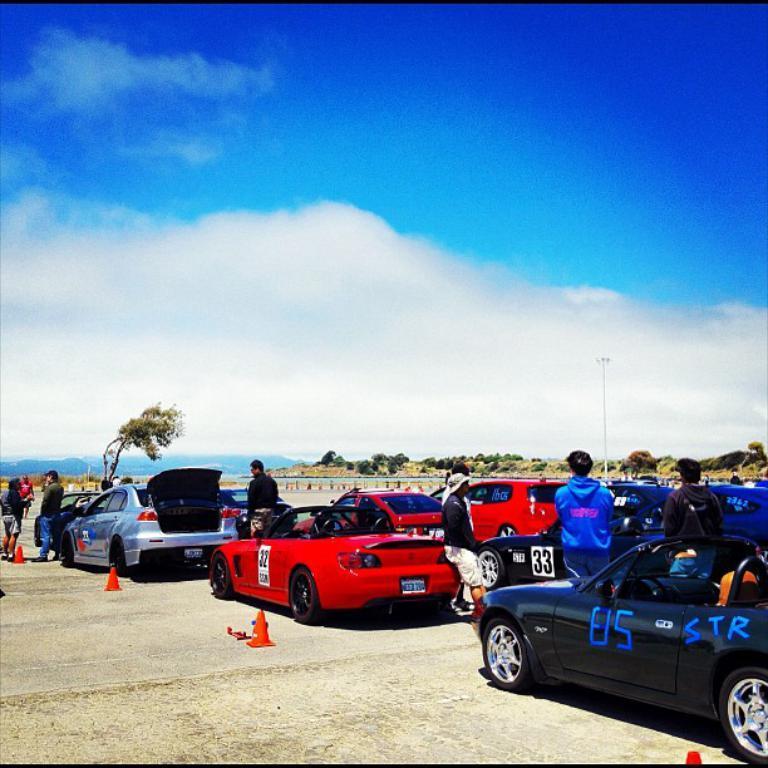Could you give a brief overview of what you see in this image? At the bottom of this image, there are vehicles, personal and small orange color poles on the road. In the background, there are trees, plants, a fence, a pole, mountains and there are clouds in the blue sky. 